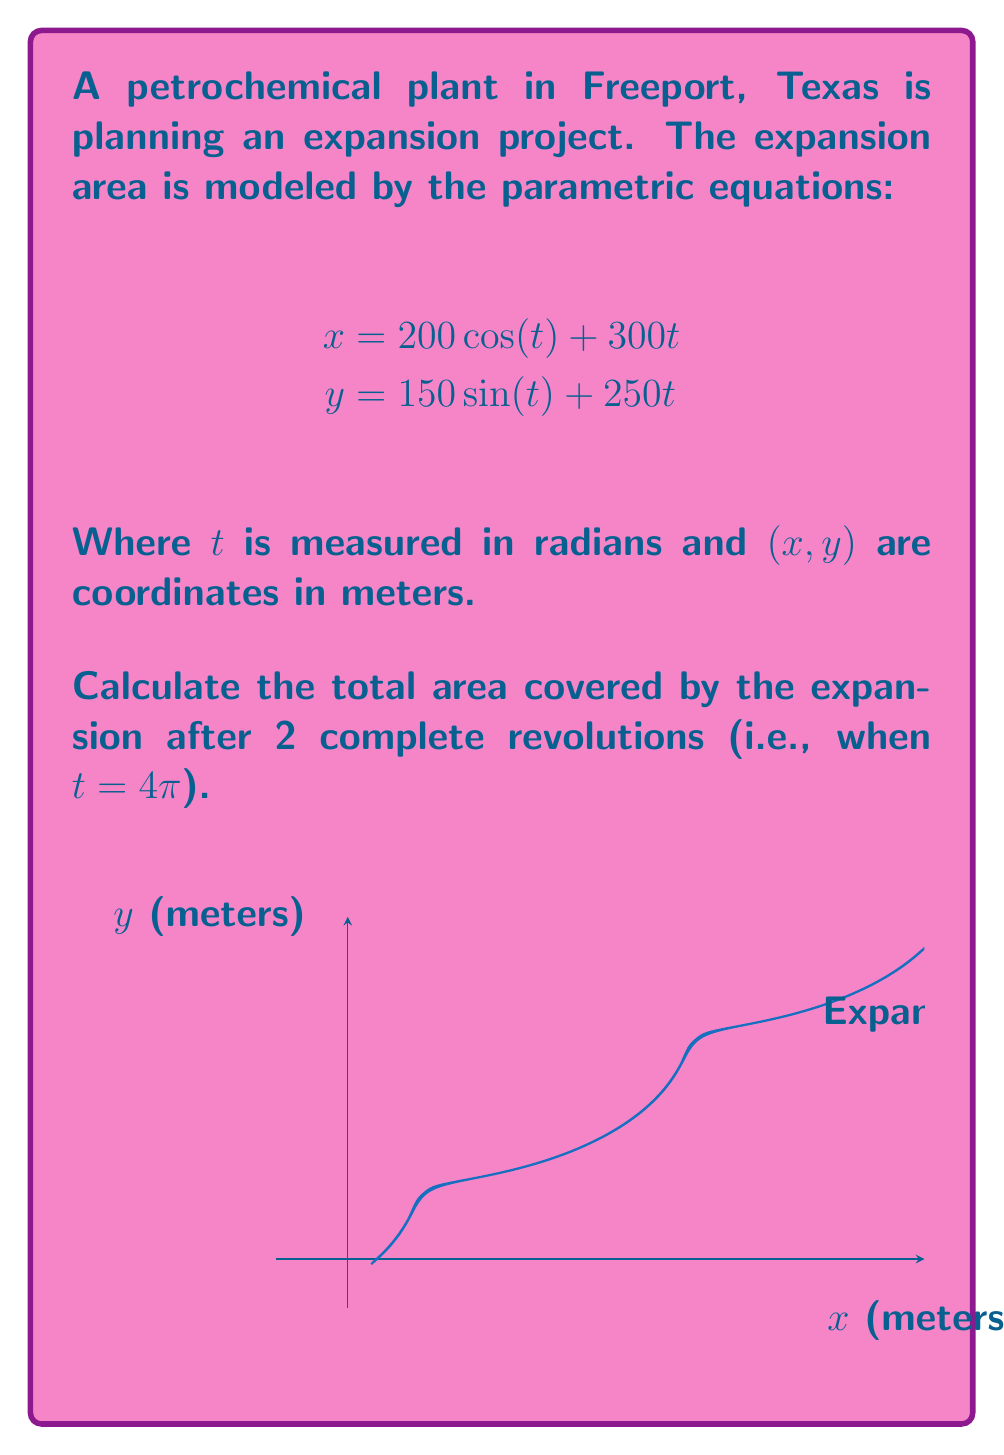What is the answer to this math problem? To solve this problem, we'll follow these steps:

1) The area enclosed by a parametric curve over an interval $[a,b]$ is given by the formula:

   $$A = \frac{1}{2}\int_a^b [x(t)y'(t) - y(t)x'(t)] dt$$

2) We need to find $x'(t)$ and $y'(t)$:
   $$x'(t) = -200\sin(t) + 300$$
   $$y'(t) = 150\cos(t) + 250$$

3) Now, let's substitute these into our area formula:

   $$A = \frac{1}{2}\int_0^{4\pi} [(200\cos(t) + 300t)(150\cos(t) + 250) - (150\sin(t) + 250t)(-200\sin(t) + 300)] dt$$

4) Expanding this:

   $$A = \frac{1}{2}\int_0^{4\pi} [30000\cos^2(t) + 50000\cos(t) + 45000t\cos(t) + 75000t + 30000\sin^2(t) + 45000t\sin(t) - 75000t] dt$$

5) Simplify using $\cos^2(t) + \sin^2(t) = 1$:

   $$A = \frac{1}{2}\int_0^{4\pi} [30000 + 50000\cos(t) + 45000t\cos(t) + 45000t\sin(t)] dt$$

6) Integrate term by term:
   
   $$A = \frac{1}{2}[30000t + 50000\sin(t) + 45000(t\sin(t) - \cos(t)) - 45000(t\cos(t) + \sin(t))]_0^{4\pi}$$

7) Evaluate at the limits:

   $$A = \frac{1}{2}[(120000\pi + 0 + 45000(-4\pi) - 0) - (0 + 0 + 45000 - 0)]$$
   
   $$A = \frac{1}{2}[120000\pi - 180000\pi - 45000]$$
   
   $$A = \frac{1}{2}[-60000\pi - 45000]$$

8) Calculate the final result:

   $$A = -30000\pi - 22500 \approx 116,592.65 \text{ square meters}$$
Answer: $116,592.65 \text{ m}^2$ 